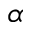Convert formula to latex. <formula><loc_0><loc_0><loc_500><loc_500>\alpha</formula> 